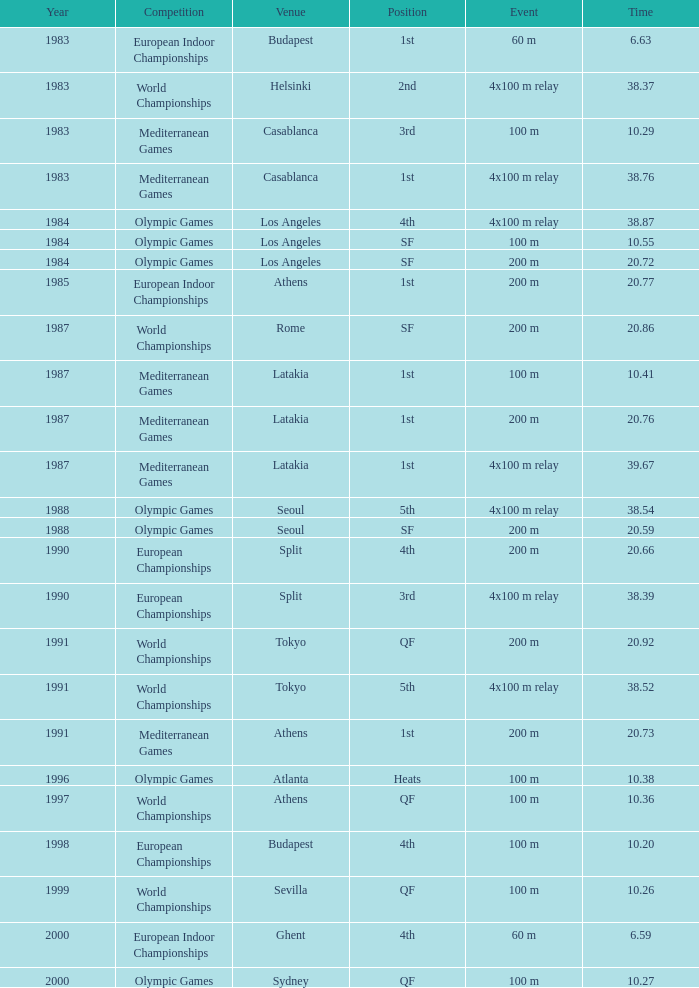Which position corresponds to a time of 20.66? 4th. 